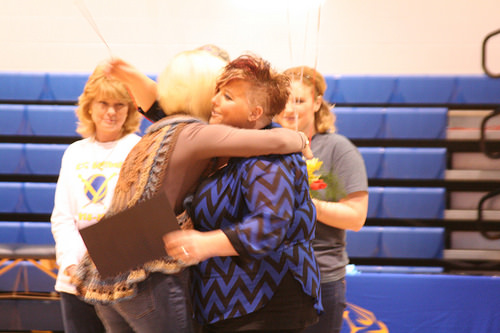<image>
Is there a woman to the left of the woman? No. The woman is not to the left of the woman. From this viewpoint, they have a different horizontal relationship. Where is the girl in relation to the woman? Is it under the woman? No. The girl is not positioned under the woman. The vertical relationship between these objects is different. Where is the woman in relation to the wall? Is it behind the wall? Yes. From this viewpoint, the woman is positioned behind the wall, with the wall partially or fully occluding the woman. Is the person one behind the person two? No. The person one is not behind the person two. From this viewpoint, the person one appears to be positioned elsewhere in the scene. 